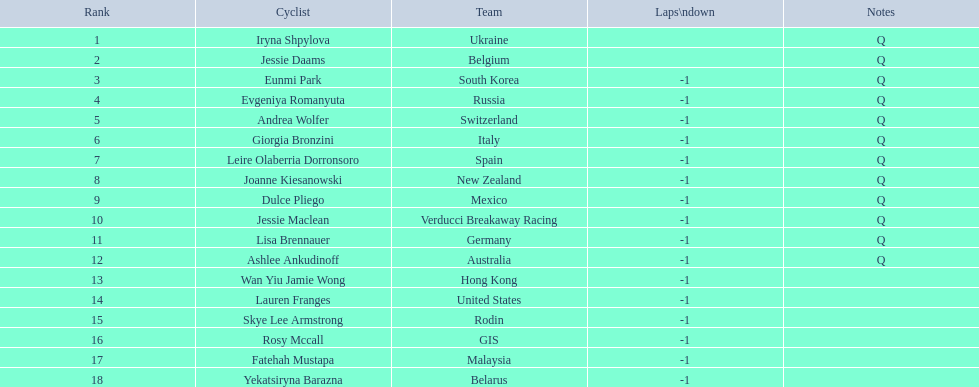Which cyclists participated? Iryna Shpylova, Jessie Daams, Eunmi Park, Evgeniya Romanyuta, Andrea Wolfer, Giorgia Bronzini, Leire Olaberria Dorronsoro, Joanne Kiesanowski, Dulce Pliego, Jessie Maclean, Lisa Brennauer, Ashlee Ankudinoff, Wan Yiu Jamie Wong, Lauren Franges, Skye Lee Armstrong, Rosy Mccall, Fatehah Mustapa, Yekatsiryna Barazna. How were they ranked? 1, 2, 3, 4, 5, 6, 7, 8, 9, 10, 11, 12, 13, 14, 15, 16, 17, 18. Who had the top position? Iryna Shpylova. 